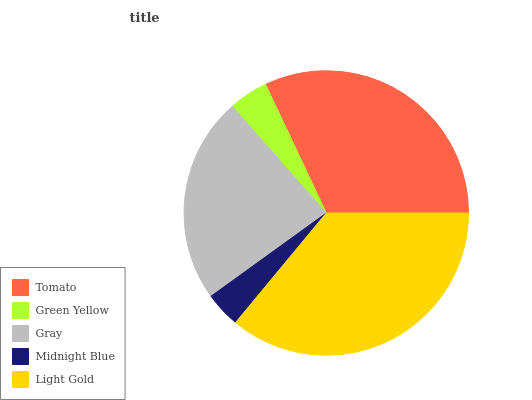Is Midnight Blue the minimum?
Answer yes or no. Yes. Is Light Gold the maximum?
Answer yes or no. Yes. Is Green Yellow the minimum?
Answer yes or no. No. Is Green Yellow the maximum?
Answer yes or no. No. Is Tomato greater than Green Yellow?
Answer yes or no. Yes. Is Green Yellow less than Tomato?
Answer yes or no. Yes. Is Green Yellow greater than Tomato?
Answer yes or no. No. Is Tomato less than Green Yellow?
Answer yes or no. No. Is Gray the high median?
Answer yes or no. Yes. Is Gray the low median?
Answer yes or no. Yes. Is Midnight Blue the high median?
Answer yes or no. No. Is Green Yellow the low median?
Answer yes or no. No. 